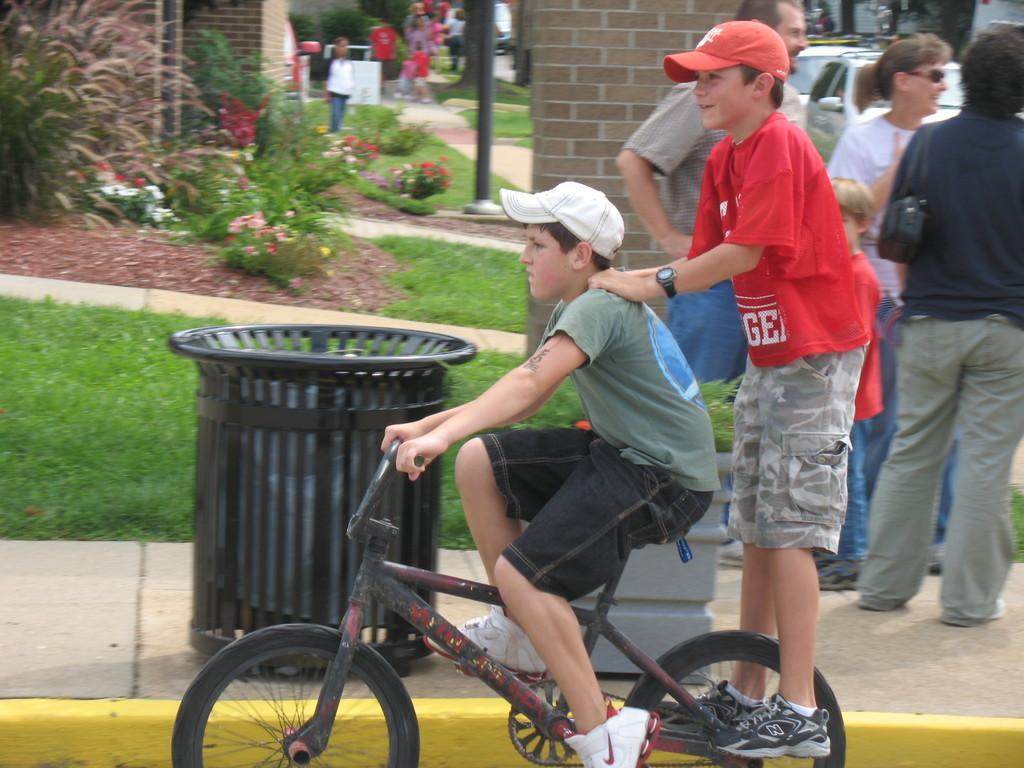Describe this image in one or two sentences. In the center we can see two persons were riding bicycle and they were wearing cap. On the right we can see two persons were standing and they were smiling. in the background there is a dust bin,brick wall,plant,flowers,grass and few more persons were standing. 